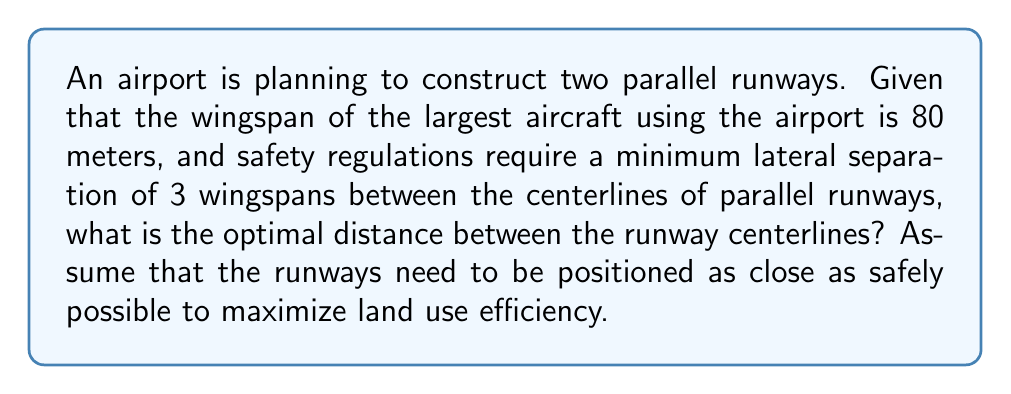Show me your answer to this math problem. Let's approach this step-by-step:

1) First, we need to understand the given information:
   - Wingspan of the largest aircraft = 80 meters
   - Safety regulation requires a minimum of 3 wingspans between centerlines

2) Calculate the minimum required separation:
   $$\text{Minimum separation} = 3 \times \text{Wingspan}$$
   $$\text{Minimum separation} = 3 \times 80 \text{ meters}$$
   $$\text{Minimum separation} = 240 \text{ meters}$$

3) The optimal distance is the minimum safe distance. Since we want to maximize land use efficiency, we should use the minimum separation allowed by safety regulations.

4) Therefore, the optimal distance between the runway centerlines is 240 meters.

[asy]
unitsize(0.5cm);
draw((-15,0)--(15,0), arrow=Arrow(TeXHead));
draw((-15,8)--(15,8), arrow=Arrow(TeXHead));
label("Runway 1", (0,-1));
label("Runway 2", (0,9));
draw((0,0)--(0,8), dashed);
label("240 m", (0,4), E);
draw((-10,0)--(-10,1.5)--(10,1.5)--(10,0));
draw((-10,8)--(-10,6.5)--(10,6.5)--(10,8));
label("80 m", (-10,0.75), W);
label("80 m", (-10,7.25), W);
[/asy]

This diagram illustrates the parallel runways and the spacing between them, showing how the 3-wingspan rule is applied.
Answer: 240 meters 